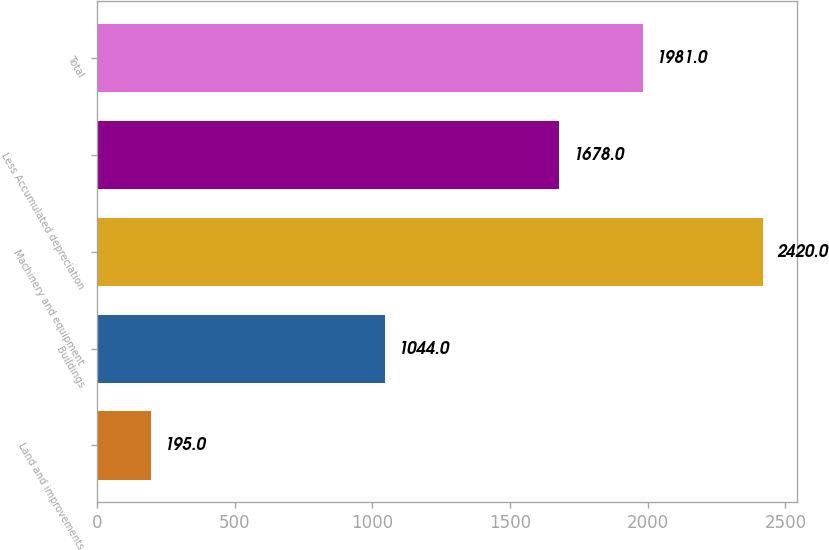<chart> <loc_0><loc_0><loc_500><loc_500><bar_chart><fcel>Land and improvements<fcel>Buildings<fcel>Machinery and equipment<fcel>Less Accumulated depreciation<fcel>Total<nl><fcel>195<fcel>1044<fcel>2420<fcel>1678<fcel>1981<nl></chart> 